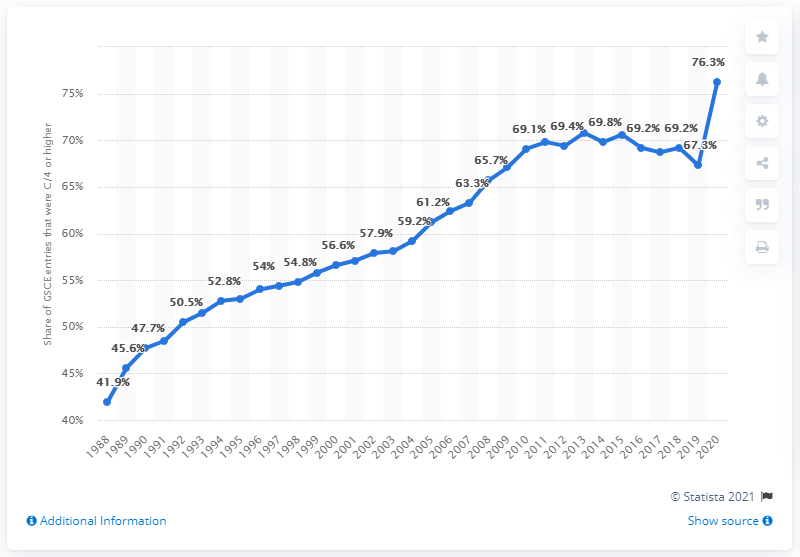Highlight a few significant elements in this photo. In 2020, the pass rate for GCSE exams in the UK was 76.3%. 